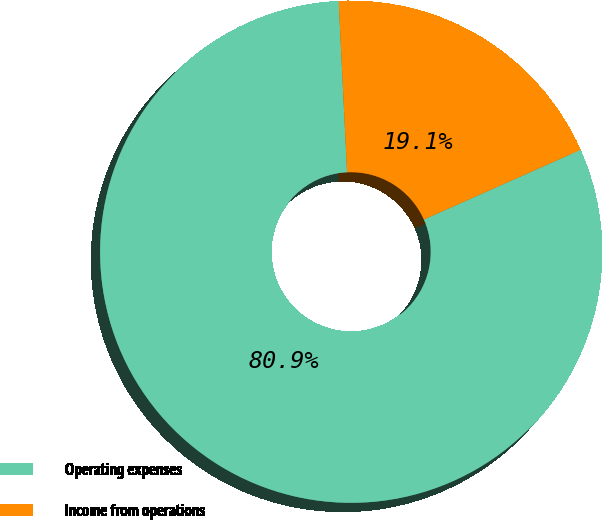Convert chart to OTSL. <chart><loc_0><loc_0><loc_500><loc_500><pie_chart><fcel>Operating expenses<fcel>Income from operations<nl><fcel>80.88%<fcel>19.12%<nl></chart> 